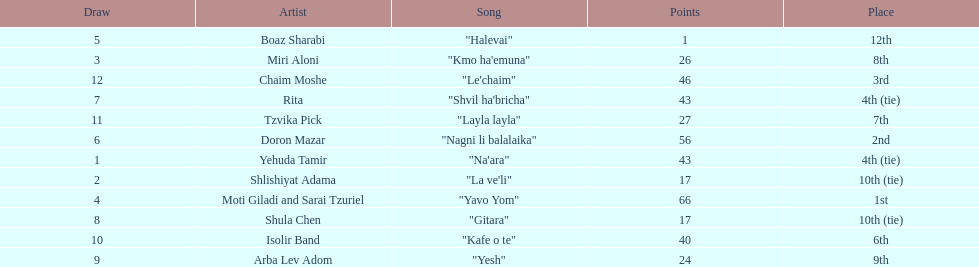Doron mazar, which artist(s) had the most points? Moti Giladi and Sarai Tzuriel. Parse the table in full. {'header': ['Draw', 'Artist', 'Song', 'Points', 'Place'], 'rows': [['5', 'Boaz Sharabi', '"Halevai"', '1', '12th'], ['3', 'Miri Aloni', '"Kmo ha\'emuna"', '26', '8th'], ['12', 'Chaim Moshe', '"Le\'chaim"', '46', '3rd'], ['7', 'Rita', '"Shvil ha\'bricha"', '43', '4th (tie)'], ['11', 'Tzvika Pick', '"Layla layla"', '27', '7th'], ['6', 'Doron Mazar', '"Nagni li balalaika"', '56', '2nd'], ['1', 'Yehuda Tamir', '"Na\'ara"', '43', '4th (tie)'], ['2', 'Shlishiyat Adama', '"La ve\'li"', '17', '10th (tie)'], ['4', 'Moti Giladi and Sarai Tzuriel', '"Yavo Yom"', '66', '1st'], ['8', 'Shula Chen', '"Gitara"', '17', '10th (tie)'], ['10', 'Isolir Band', '"Kafe o te"', '40', '6th'], ['9', 'Arba Lev Adom', '"Yesh"', '24', '9th']]} 